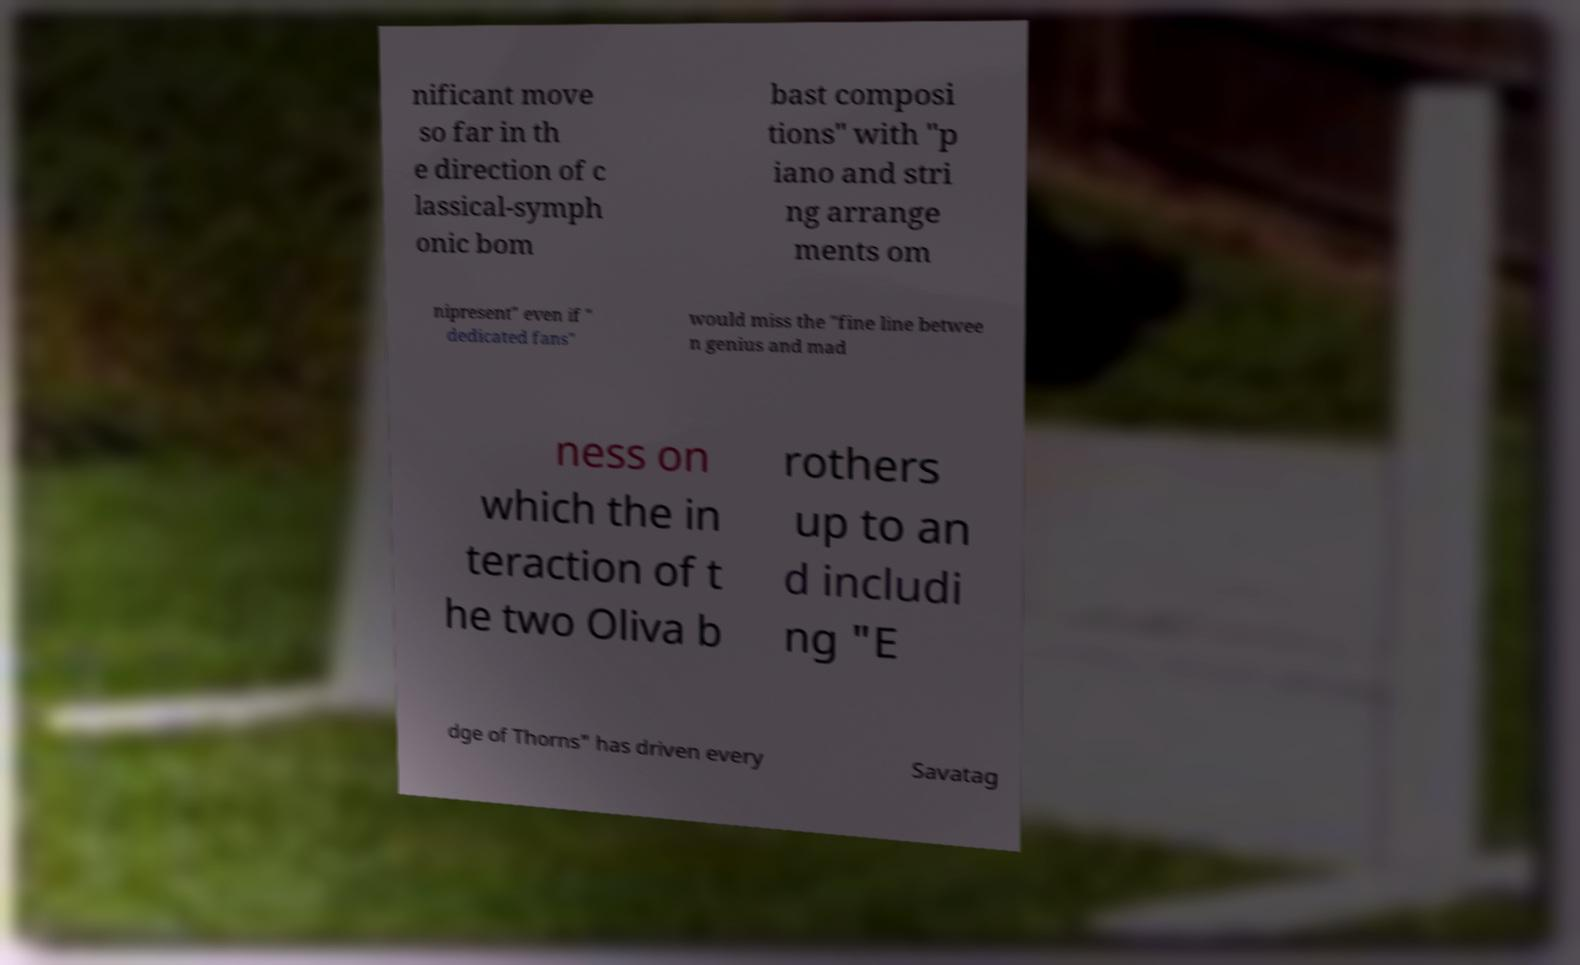I need the written content from this picture converted into text. Can you do that? nificant move so far in th e direction of c lassical-symph onic bom bast composi tions" with "p iano and stri ng arrange ments om nipresent" even if " dedicated fans" would miss the "fine line betwee n genius and mad ness on which the in teraction of t he two Oliva b rothers up to an d includi ng "E dge of Thorns" has driven every Savatag 